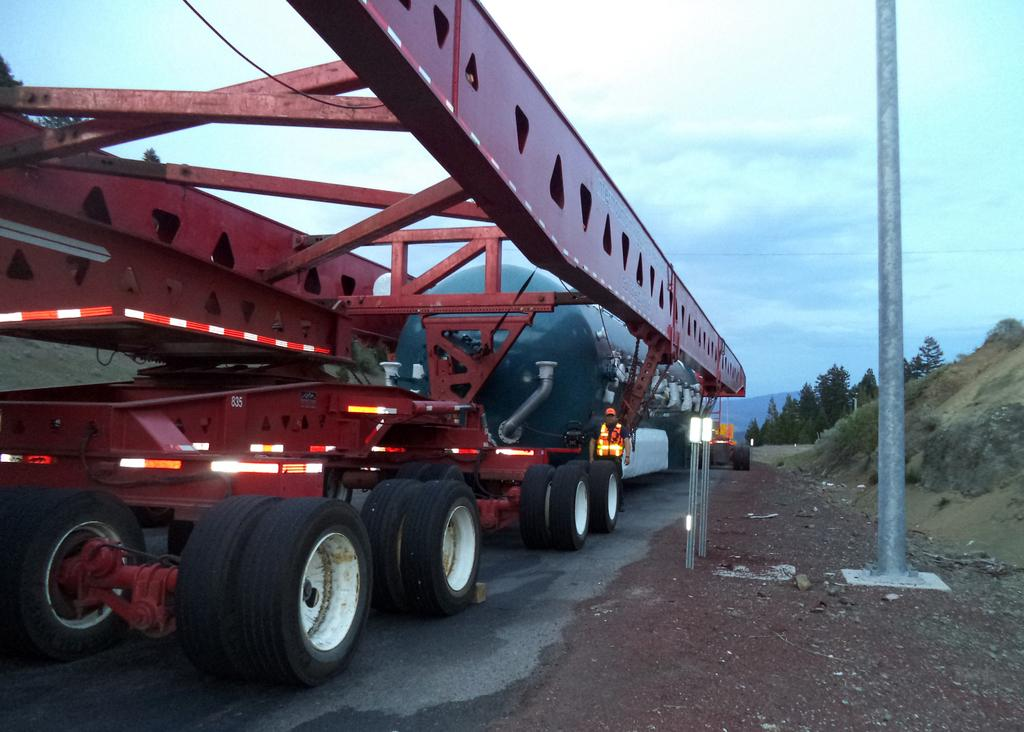What is happening on the road in the image? There are vehicles on the road in the image. Can you describe the person in front of a vehicle? A person is visible in front of a vehicle. What else can be seen in the image besides the vehicles and person? There is a pole, the sky, a hill, and trees visible in the image. How many bikes are being ridden by the stranger in the image? There is no stranger or bikes present in the image. What type of police vehicle can be seen in the image? There is no police vehicle present in the image. 